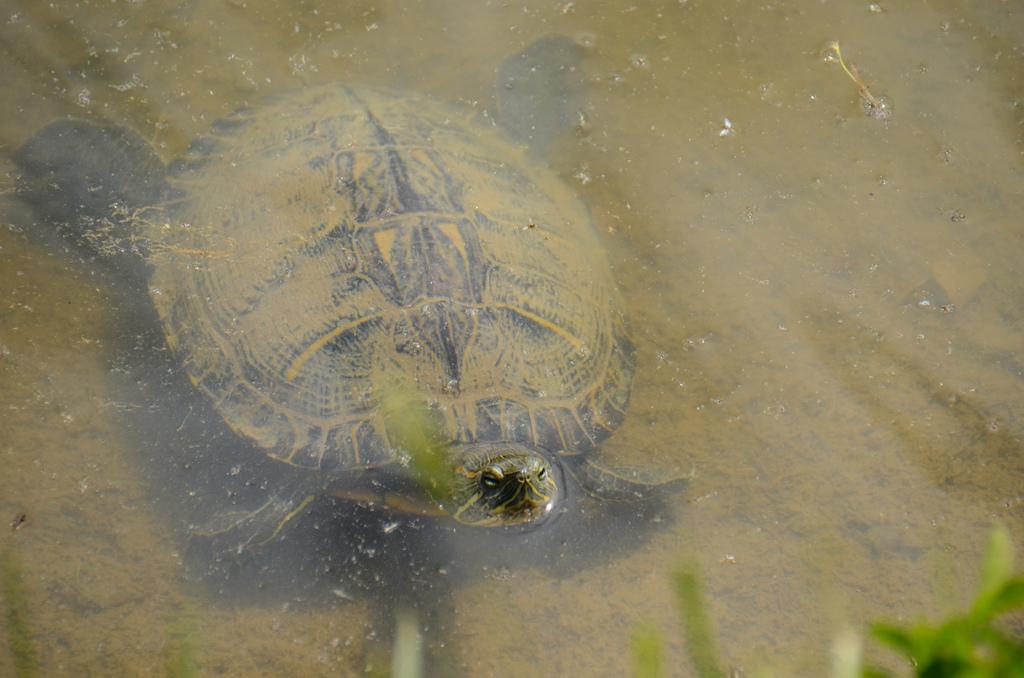Describe this image in one or two sentences. In this picture, we see the turtle is swimming in the water and this water might be in the pond. In the right bottom, we see the aquatic plants or grass. 